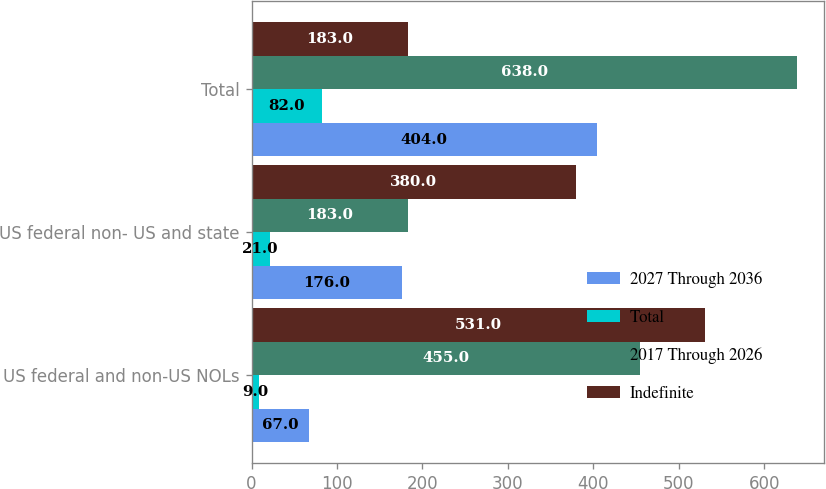Convert chart. <chart><loc_0><loc_0><loc_500><loc_500><stacked_bar_chart><ecel><fcel>US federal and non-US NOLs<fcel>US federal non- US and state<fcel>Total<nl><fcel>2027 Through 2036<fcel>67<fcel>176<fcel>404<nl><fcel>Total<fcel>9<fcel>21<fcel>82<nl><fcel>2017 Through 2026<fcel>455<fcel>183<fcel>638<nl><fcel>Indefinite<fcel>531<fcel>380<fcel>183<nl></chart> 